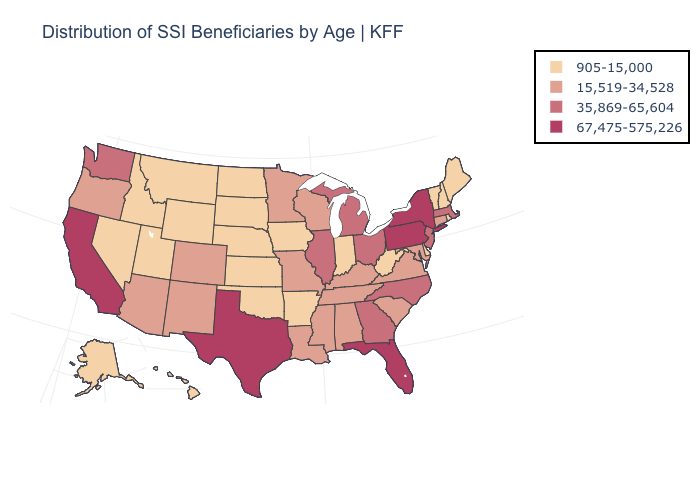Is the legend a continuous bar?
Keep it brief. No. What is the value of Massachusetts?
Keep it brief. 35,869-65,604. Name the states that have a value in the range 35,869-65,604?
Quick response, please. Georgia, Illinois, Massachusetts, Michigan, New Jersey, North Carolina, Ohio, Washington. Does Utah have a higher value than Florida?
Concise answer only. No. Among the states that border Delaware , does Pennsylvania have the highest value?
Write a very short answer. Yes. Name the states that have a value in the range 905-15,000?
Concise answer only. Alaska, Arkansas, Delaware, Hawaii, Idaho, Indiana, Iowa, Kansas, Maine, Montana, Nebraska, Nevada, New Hampshire, North Dakota, Oklahoma, Rhode Island, South Dakota, Utah, Vermont, West Virginia, Wyoming. Name the states that have a value in the range 35,869-65,604?
Answer briefly. Georgia, Illinois, Massachusetts, Michigan, New Jersey, North Carolina, Ohio, Washington. Does Wyoming have a higher value than Michigan?
Concise answer only. No. What is the value of Connecticut?
Quick response, please. 15,519-34,528. Does Florida have a higher value than Texas?
Keep it brief. No. Does Louisiana have a higher value than Iowa?
Short answer required. Yes. Name the states that have a value in the range 15,519-34,528?
Quick response, please. Alabama, Arizona, Colorado, Connecticut, Kentucky, Louisiana, Maryland, Minnesota, Mississippi, Missouri, New Mexico, Oregon, South Carolina, Tennessee, Virginia, Wisconsin. Name the states that have a value in the range 67,475-575,226?
Concise answer only. California, Florida, New York, Pennsylvania, Texas. What is the lowest value in the USA?
Answer briefly. 905-15,000. Does Ohio have a higher value than California?
Answer briefly. No. 